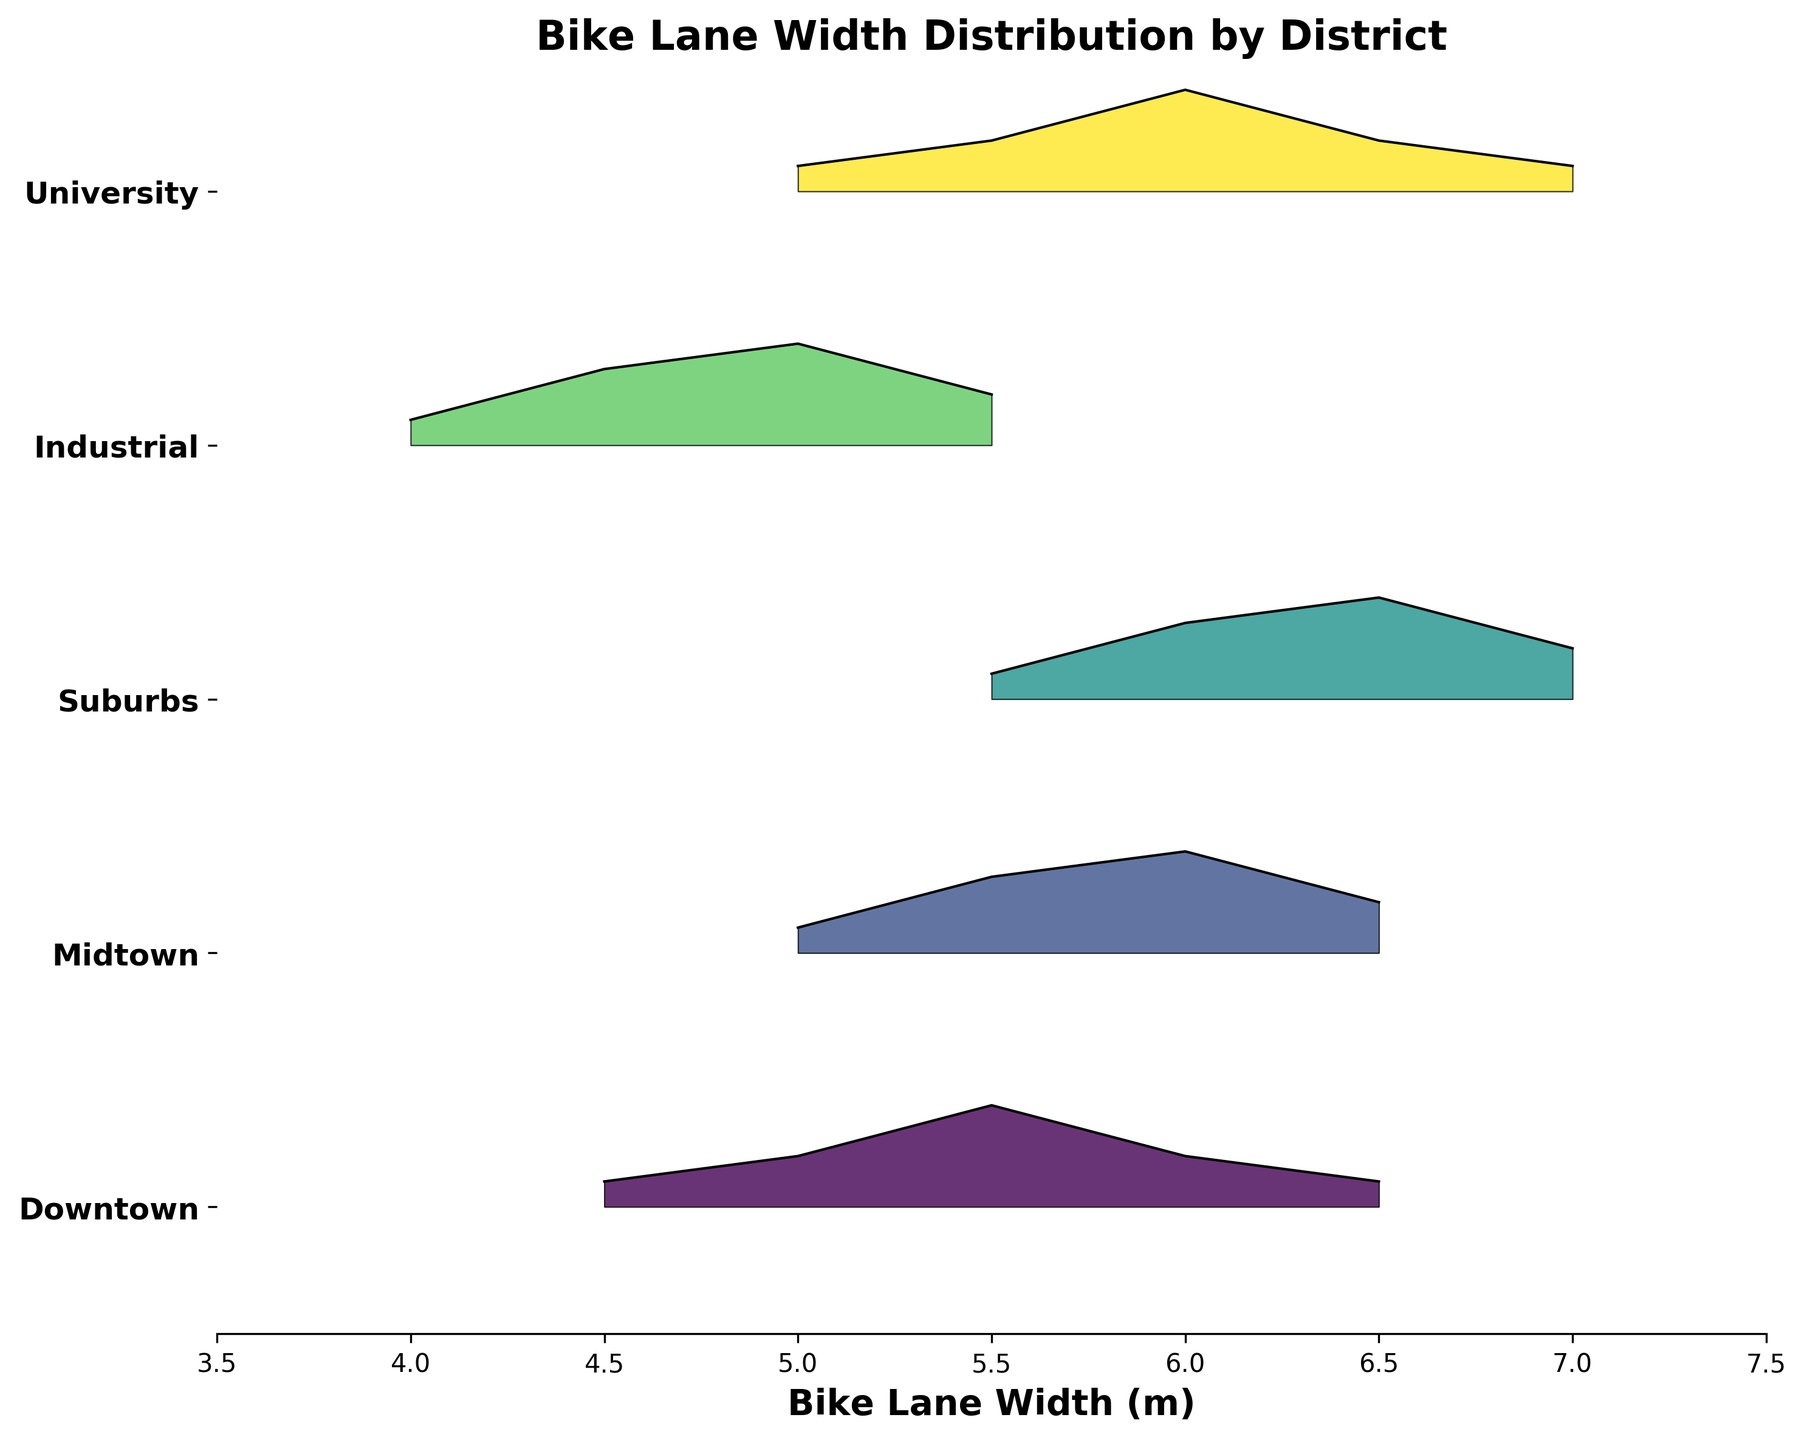What is the title of the plot? The title of the plot is displayed at the top of the figure. It provides a summary of what the figure represents.
Answer: Bike Lane Width Distribution by District Which district has the widest bike lane in terms of mode width? To find the district with the widest mode width, look for the district with the highest peak on the far right side of the plot.
Answer: Suburbs Which district has the narrowest bike lane in terms of mode width? To find the district with the narrowest mode width, look for the district with the highest peak on the far left side of the plot.
Answer: Industrial Which district shows the most variation in bike lane widths? Variation can be observed by looking at the spread of the distribution for each district. The district with the widest spread has the most variation.
Answer: Suburbs Which district has the highest density of a particular bike lane width? The highest density can be identified by looking for the tallest peak in any of the districts' curves.
Answer: Midtown Are there any districts where bike lanes are consistently above 6 meters in width? To check for this, look at the sections of the plot above 6 meters. If a district has a consistent density across this range, it indicates wider lanes.
Answer: Suburbs Which two districts have the most similar distributions in bike lane widths? Similar distributions can be identified by finding districts where the shapes and peaks of the curves are alike.
Answer: Downtown and University How does the bike lane width distribution in Downtown compare to Midtown? Comparing the two distributions involves looking at their overlap, peak widths, and general spread on the plot.
Answer: Downtown has narrower lanes than Midtown What is the range of bike lane widths found in the Suburbs? The range of bike lane widths can be identified by looking at the minimum and maximum bike lane widths that have density values in the Suburbs' distribution.
Answer: 5.5 to 7.0 meters How does the density of bike lane widths in the Industrial district compare to that in the University district? Comparing densities involves looking at the height of the peaks for various widths in both districts.
Answer: Industrial has a higher density at narrow widths (4.0 to 5.0) 